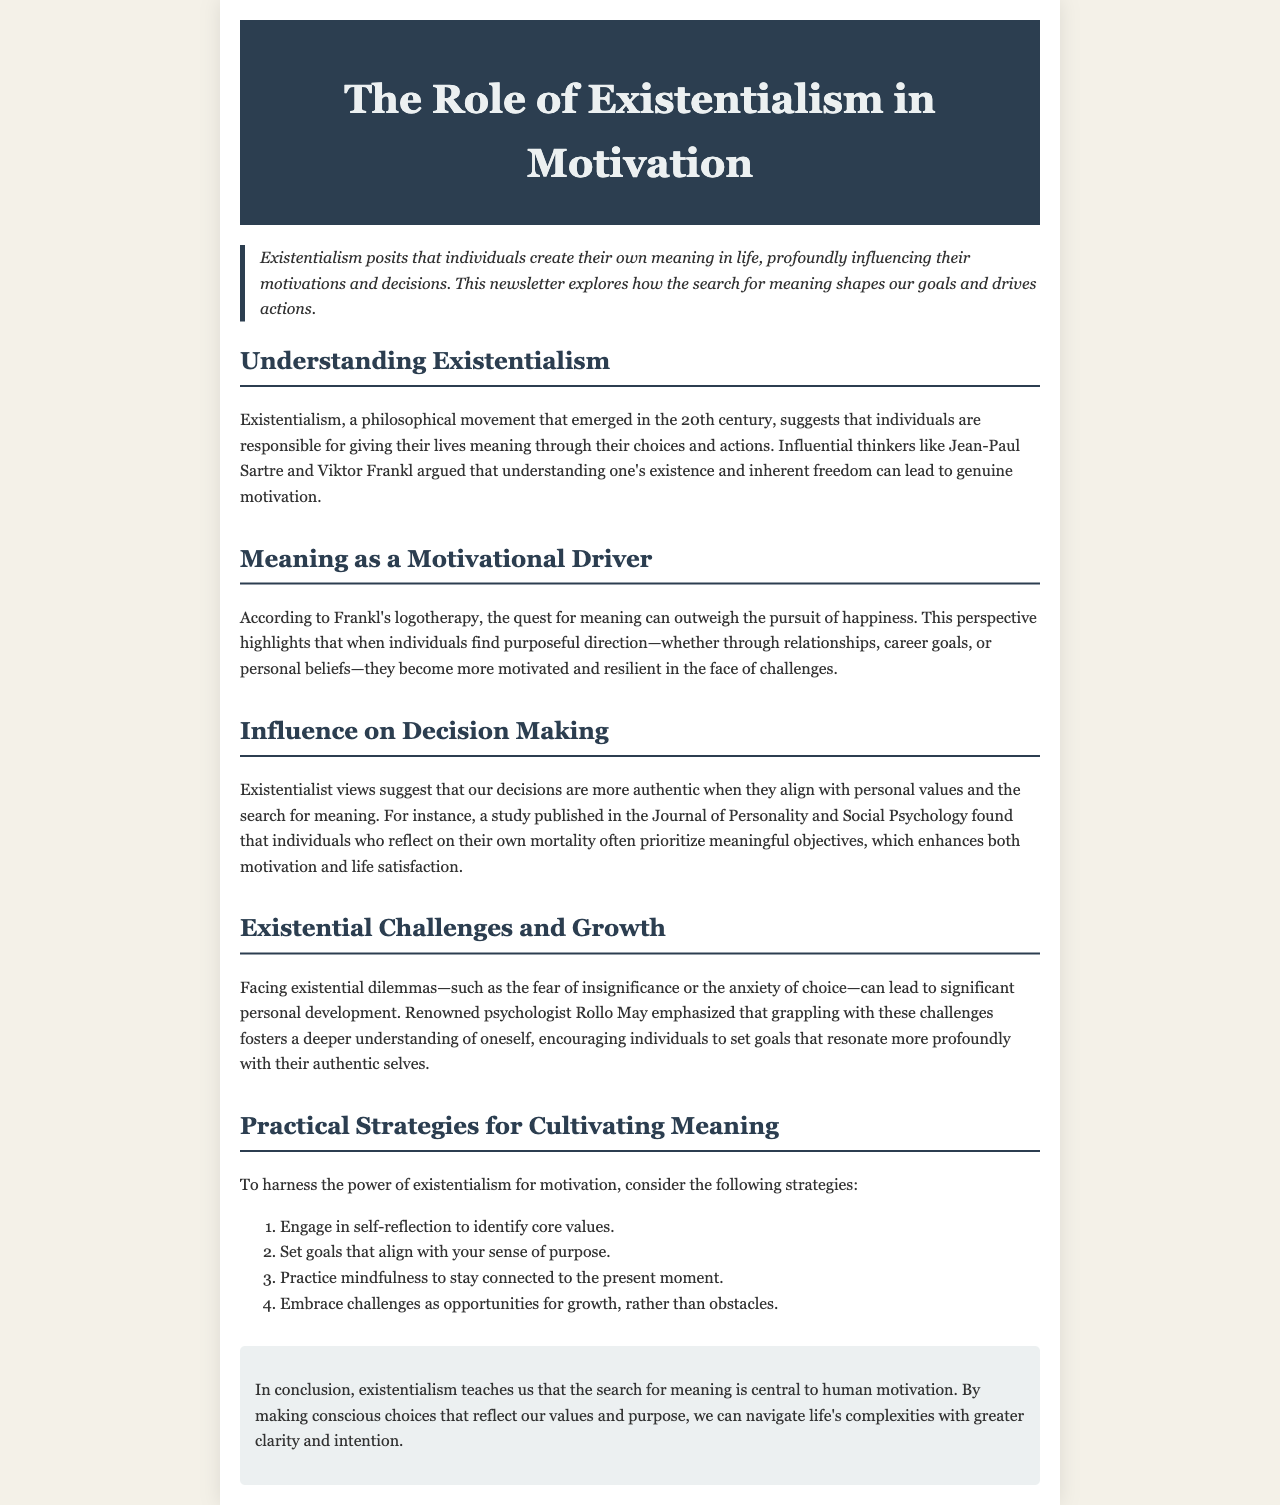What philosophical movement is discussed in the newsletter? The newsletter discusses existentialism as a philosophical movement that emerged in the 20th century.
Answer: existentialism Who are two influential thinkers mentioned in the document? The document mentions Jean-Paul Sartre and Viktor Frankl as influential thinkers in existentialism.
Answer: Jean-Paul Sartre and Viktor Frankl What does logotherapy emphasize about the quest for meaning? According to Frankl's logotherapy, the quest for meaning can outweigh the pursuit of happiness.
Answer: outweigh the pursuit of happiness What was the focus of the study published in the Journal of Personality and Social Psychology? The study found that individuals who reflect on their own mortality prioritize meaningful objectives.
Answer: meaningful objectives What are the first two practical strategies for cultivating meaning listed in the document? The strategies include engaging in self-reflection to identify core values and setting goals that align with your sense of purpose.
Answer: self-reflection and setting goals What does Rollo May suggest grappling with existential dilemmas leads to? Rollo May emphasized that grappling with existential dilemmas fosters a deeper understanding of oneself.
Answer: deeper understanding of oneself What is the central theme of the newsletter's conclusion? The conclusion emphasizes that the search for meaning is central to human motivation.
Answer: search for meaning is central to human motivation 